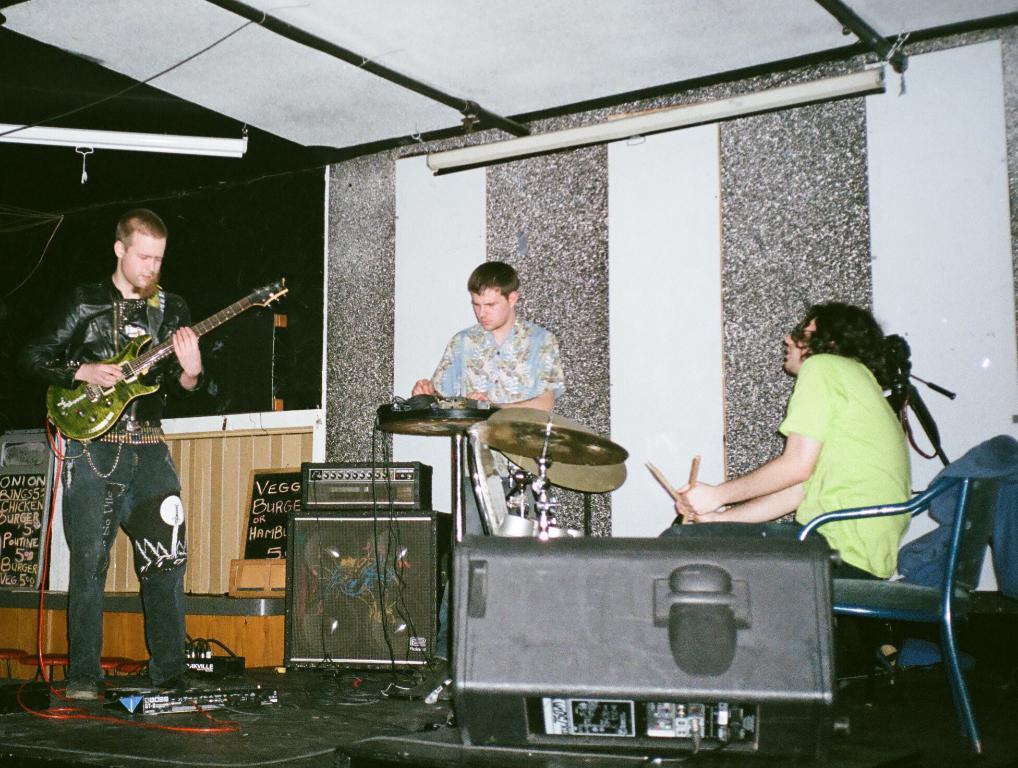Please provide a concise description of this image. In this Image I see 3 men, in which one of them is sitting on chair and holding sticks and rest of them are standing they're with their musical instruments. I can also see few equipment over here. 